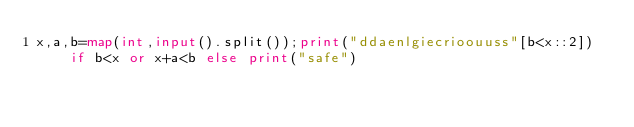<code> <loc_0><loc_0><loc_500><loc_500><_Python_>x,a,b=map(int,input().split());print("ddaenlgiecrioouuss"[b<x::2]) if b<x or x+a<b else print("safe")</code> 